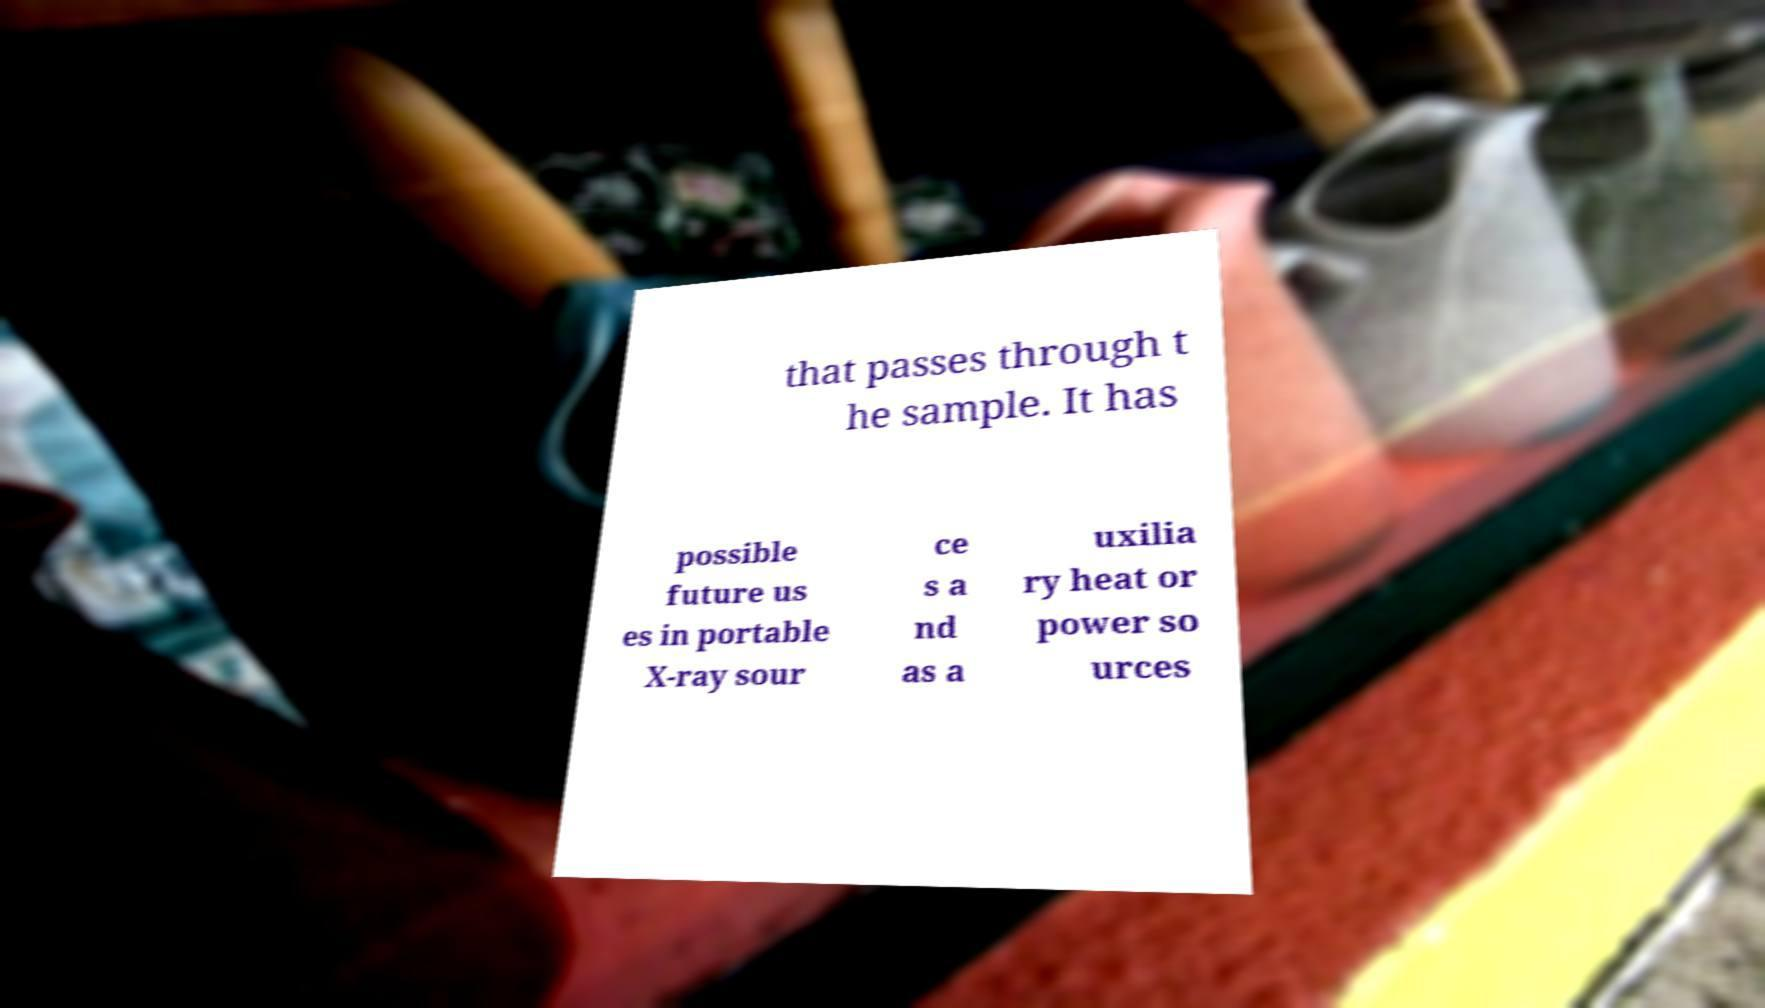Can you read and provide the text displayed in the image?This photo seems to have some interesting text. Can you extract and type it out for me? that passes through t he sample. It has possible future us es in portable X-ray sour ce s a nd as a uxilia ry heat or power so urces 